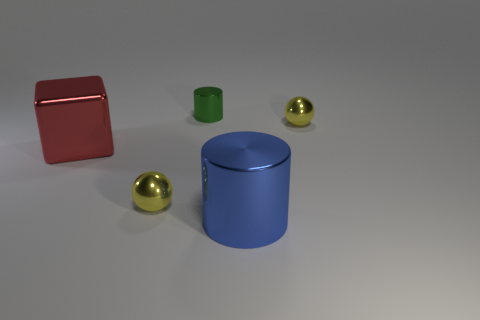What time of day and setting does this scene represent? The image seems to depict an indoor setting with neutral lighting, likely rendered to simulate a studio environment without specific indications of the time of day. Do the objects look like they are in motion or stationary? All objects appear to be stationary, resting on a flat surface with no signs of motion or dynamic activity. 